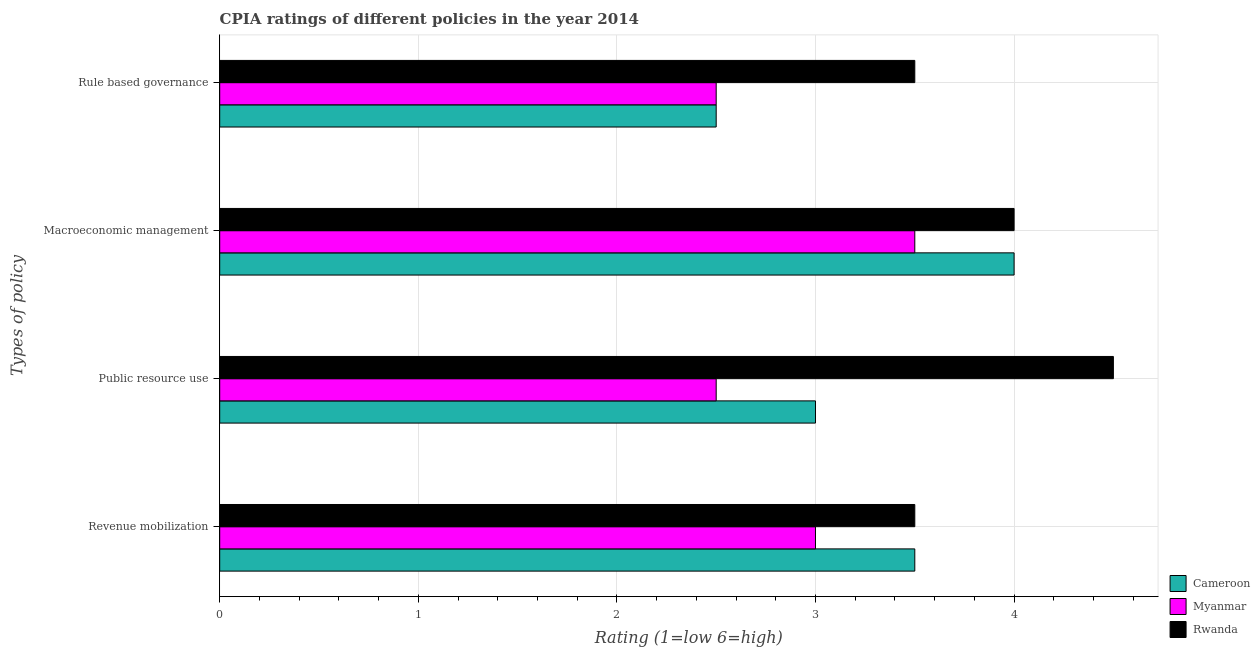How many different coloured bars are there?
Keep it short and to the point. 3. Are the number of bars per tick equal to the number of legend labels?
Provide a short and direct response. Yes. Are the number of bars on each tick of the Y-axis equal?
Ensure brevity in your answer.  Yes. How many bars are there on the 4th tick from the bottom?
Ensure brevity in your answer.  3. What is the label of the 3rd group of bars from the top?
Make the answer very short. Public resource use. Across all countries, what is the maximum cpia rating of revenue mobilization?
Provide a short and direct response. 3.5. In which country was the cpia rating of rule based governance maximum?
Give a very brief answer. Rwanda. In which country was the cpia rating of public resource use minimum?
Your answer should be very brief. Myanmar. What is the total cpia rating of rule based governance in the graph?
Provide a short and direct response. 8.5. What is the difference between the cpia rating of macroeconomic management in Rwanda and that in Cameroon?
Your answer should be very brief. 0. What is the difference between the cpia rating of rule based governance in Cameroon and the cpia rating of public resource use in Myanmar?
Provide a short and direct response. 0. What is the average cpia rating of revenue mobilization per country?
Make the answer very short. 3.33. In how many countries, is the cpia rating of rule based governance greater than 3.6 ?
Your answer should be very brief. 0. What is the ratio of the cpia rating of revenue mobilization in Rwanda to that in Myanmar?
Provide a succinct answer. 1.17. What is the difference between the highest and the lowest cpia rating of public resource use?
Offer a very short reply. 2. Is the sum of the cpia rating of revenue mobilization in Cameroon and Myanmar greater than the maximum cpia rating of macroeconomic management across all countries?
Your answer should be compact. Yes. Is it the case that in every country, the sum of the cpia rating of revenue mobilization and cpia rating of macroeconomic management is greater than the sum of cpia rating of public resource use and cpia rating of rule based governance?
Make the answer very short. Yes. What does the 2nd bar from the top in Rule based governance represents?
Offer a terse response. Myanmar. What does the 3rd bar from the bottom in Macroeconomic management represents?
Give a very brief answer. Rwanda. Is it the case that in every country, the sum of the cpia rating of revenue mobilization and cpia rating of public resource use is greater than the cpia rating of macroeconomic management?
Your answer should be compact. Yes. How many bars are there?
Offer a terse response. 12. Are the values on the major ticks of X-axis written in scientific E-notation?
Offer a very short reply. No. Does the graph contain any zero values?
Provide a short and direct response. No. Does the graph contain grids?
Ensure brevity in your answer.  Yes. Where does the legend appear in the graph?
Your answer should be compact. Bottom right. How many legend labels are there?
Provide a succinct answer. 3. How are the legend labels stacked?
Your response must be concise. Vertical. What is the title of the graph?
Offer a very short reply. CPIA ratings of different policies in the year 2014. What is the label or title of the X-axis?
Your answer should be very brief. Rating (1=low 6=high). What is the label or title of the Y-axis?
Offer a terse response. Types of policy. What is the Rating (1=low 6=high) in Cameroon in Revenue mobilization?
Ensure brevity in your answer.  3.5. What is the Rating (1=low 6=high) of Myanmar in Revenue mobilization?
Make the answer very short. 3. What is the Rating (1=low 6=high) of Cameroon in Public resource use?
Your answer should be very brief. 3. What is the Rating (1=low 6=high) in Rwanda in Public resource use?
Offer a terse response. 4.5. What is the Rating (1=low 6=high) in Rwanda in Macroeconomic management?
Your answer should be very brief. 4. Across all Types of policy, what is the maximum Rating (1=low 6=high) in Cameroon?
Provide a short and direct response. 4. Across all Types of policy, what is the maximum Rating (1=low 6=high) in Rwanda?
Give a very brief answer. 4.5. Across all Types of policy, what is the minimum Rating (1=low 6=high) of Cameroon?
Make the answer very short. 2.5. Across all Types of policy, what is the minimum Rating (1=low 6=high) in Myanmar?
Offer a terse response. 2.5. What is the total Rating (1=low 6=high) of Myanmar in the graph?
Keep it short and to the point. 11.5. What is the total Rating (1=low 6=high) of Rwanda in the graph?
Your answer should be compact. 15.5. What is the difference between the Rating (1=low 6=high) in Myanmar in Revenue mobilization and that in Public resource use?
Your answer should be compact. 0.5. What is the difference between the Rating (1=low 6=high) in Cameroon in Public resource use and that in Macroeconomic management?
Provide a short and direct response. -1. What is the difference between the Rating (1=low 6=high) of Rwanda in Public resource use and that in Macroeconomic management?
Provide a succinct answer. 0.5. What is the difference between the Rating (1=low 6=high) in Rwanda in Public resource use and that in Rule based governance?
Provide a succinct answer. 1. What is the difference between the Rating (1=low 6=high) in Myanmar in Revenue mobilization and the Rating (1=low 6=high) in Rwanda in Public resource use?
Give a very brief answer. -1.5. What is the difference between the Rating (1=low 6=high) of Cameroon in Revenue mobilization and the Rating (1=low 6=high) of Myanmar in Macroeconomic management?
Provide a short and direct response. 0. What is the difference between the Rating (1=low 6=high) of Cameroon in Revenue mobilization and the Rating (1=low 6=high) of Rwanda in Macroeconomic management?
Keep it short and to the point. -0.5. What is the difference between the Rating (1=low 6=high) of Myanmar in Revenue mobilization and the Rating (1=low 6=high) of Rwanda in Macroeconomic management?
Ensure brevity in your answer.  -1. What is the difference between the Rating (1=low 6=high) in Myanmar in Revenue mobilization and the Rating (1=low 6=high) in Rwanda in Rule based governance?
Offer a terse response. -0.5. What is the difference between the Rating (1=low 6=high) in Cameroon in Public resource use and the Rating (1=low 6=high) in Myanmar in Macroeconomic management?
Provide a succinct answer. -0.5. What is the difference between the Rating (1=low 6=high) in Myanmar in Public resource use and the Rating (1=low 6=high) in Rwanda in Macroeconomic management?
Provide a succinct answer. -1.5. What is the difference between the Rating (1=low 6=high) in Cameroon in Public resource use and the Rating (1=low 6=high) in Myanmar in Rule based governance?
Keep it short and to the point. 0.5. What is the difference between the Rating (1=low 6=high) of Cameroon in Macroeconomic management and the Rating (1=low 6=high) of Myanmar in Rule based governance?
Ensure brevity in your answer.  1.5. What is the difference between the Rating (1=low 6=high) of Cameroon in Macroeconomic management and the Rating (1=low 6=high) of Rwanda in Rule based governance?
Keep it short and to the point. 0.5. What is the average Rating (1=low 6=high) of Cameroon per Types of policy?
Your answer should be very brief. 3.25. What is the average Rating (1=low 6=high) in Myanmar per Types of policy?
Offer a very short reply. 2.88. What is the average Rating (1=low 6=high) in Rwanda per Types of policy?
Ensure brevity in your answer.  3.88. What is the difference between the Rating (1=low 6=high) in Cameroon and Rating (1=low 6=high) in Myanmar in Revenue mobilization?
Your response must be concise. 0.5. What is the difference between the Rating (1=low 6=high) of Cameroon and Rating (1=low 6=high) of Rwanda in Revenue mobilization?
Your response must be concise. 0. What is the difference between the Rating (1=low 6=high) of Cameroon and Rating (1=low 6=high) of Rwanda in Public resource use?
Your response must be concise. -1.5. What is the difference between the Rating (1=low 6=high) of Myanmar and Rating (1=low 6=high) of Rwanda in Public resource use?
Your answer should be very brief. -2. What is the difference between the Rating (1=low 6=high) in Cameroon and Rating (1=low 6=high) in Rwanda in Macroeconomic management?
Your response must be concise. 0. What is the difference between the Rating (1=low 6=high) of Cameroon and Rating (1=low 6=high) of Myanmar in Rule based governance?
Give a very brief answer. 0. What is the ratio of the Rating (1=low 6=high) in Myanmar in Revenue mobilization to that in Public resource use?
Ensure brevity in your answer.  1.2. What is the ratio of the Rating (1=low 6=high) in Rwanda in Revenue mobilization to that in Public resource use?
Give a very brief answer. 0.78. What is the ratio of the Rating (1=low 6=high) of Cameroon in Revenue mobilization to that in Macroeconomic management?
Give a very brief answer. 0.88. What is the ratio of the Rating (1=low 6=high) in Myanmar in Revenue mobilization to that in Macroeconomic management?
Provide a short and direct response. 0.86. What is the ratio of the Rating (1=low 6=high) in Myanmar in Revenue mobilization to that in Rule based governance?
Make the answer very short. 1.2. What is the ratio of the Rating (1=low 6=high) of Rwanda in Revenue mobilization to that in Rule based governance?
Provide a succinct answer. 1. What is the ratio of the Rating (1=low 6=high) in Cameroon in Public resource use to that in Macroeconomic management?
Give a very brief answer. 0.75. What is the ratio of the Rating (1=low 6=high) of Myanmar in Public resource use to that in Macroeconomic management?
Your answer should be very brief. 0.71. What is the ratio of the Rating (1=low 6=high) of Rwanda in Public resource use to that in Macroeconomic management?
Offer a very short reply. 1.12. What is the ratio of the Rating (1=low 6=high) of Cameroon in Public resource use to that in Rule based governance?
Your response must be concise. 1.2. What is the ratio of the Rating (1=low 6=high) in Rwanda in Public resource use to that in Rule based governance?
Offer a very short reply. 1.29. What is the ratio of the Rating (1=low 6=high) in Myanmar in Macroeconomic management to that in Rule based governance?
Keep it short and to the point. 1.4. What is the ratio of the Rating (1=low 6=high) in Rwanda in Macroeconomic management to that in Rule based governance?
Provide a short and direct response. 1.14. What is the difference between the highest and the second highest Rating (1=low 6=high) in Cameroon?
Provide a short and direct response. 0.5. What is the difference between the highest and the second highest Rating (1=low 6=high) in Myanmar?
Keep it short and to the point. 0.5. What is the difference between the highest and the second highest Rating (1=low 6=high) of Rwanda?
Provide a succinct answer. 0.5. What is the difference between the highest and the lowest Rating (1=low 6=high) of Cameroon?
Your response must be concise. 1.5. What is the difference between the highest and the lowest Rating (1=low 6=high) in Myanmar?
Offer a terse response. 1. What is the difference between the highest and the lowest Rating (1=low 6=high) of Rwanda?
Make the answer very short. 1. 